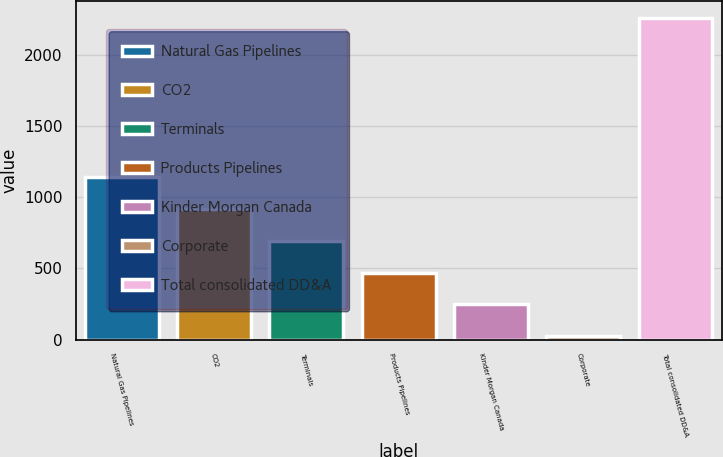Convert chart to OTSL. <chart><loc_0><loc_0><loc_500><loc_500><bar_chart><fcel>Natural Gas Pipelines<fcel>CO2<fcel>Terminals<fcel>Products Pipelines<fcel>Kinder Morgan Canada<fcel>Corporate<fcel>Total consolidated DD&A<nl><fcel>1142<fcel>918.2<fcel>694.4<fcel>470.6<fcel>246.8<fcel>23<fcel>2261<nl></chart> 